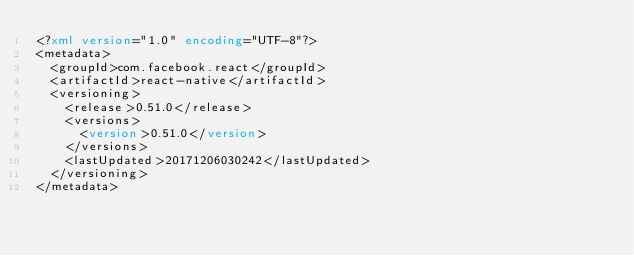<code> <loc_0><loc_0><loc_500><loc_500><_XML_><?xml version="1.0" encoding="UTF-8"?>
<metadata>
  <groupId>com.facebook.react</groupId>
  <artifactId>react-native</artifactId>
  <versioning>
    <release>0.51.0</release>
    <versions>
      <version>0.51.0</version>
    </versions>
    <lastUpdated>20171206030242</lastUpdated>
  </versioning>
</metadata>
</code> 